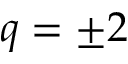<formula> <loc_0><loc_0><loc_500><loc_500>q = \pm 2</formula> 